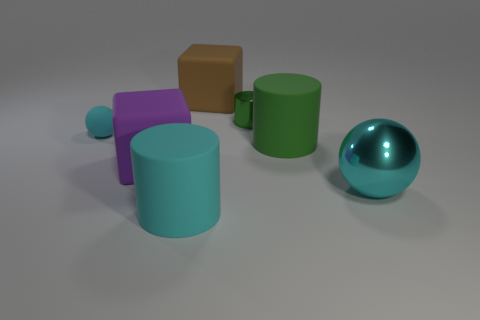Subtract all big cylinders. How many cylinders are left? 1 Add 2 green matte objects. How many objects exist? 9 Subtract all green cylinders. How many cylinders are left? 1 Subtract 1 cylinders. How many cylinders are left? 2 Subtract 0 gray balls. How many objects are left? 7 Subtract all cylinders. How many objects are left? 4 Subtract all blue spheres. Subtract all purple blocks. How many spheres are left? 2 Subtract all blue blocks. How many cyan cylinders are left? 1 Subtract all large cyan spheres. Subtract all green things. How many objects are left? 4 Add 5 tiny cylinders. How many tiny cylinders are left? 6 